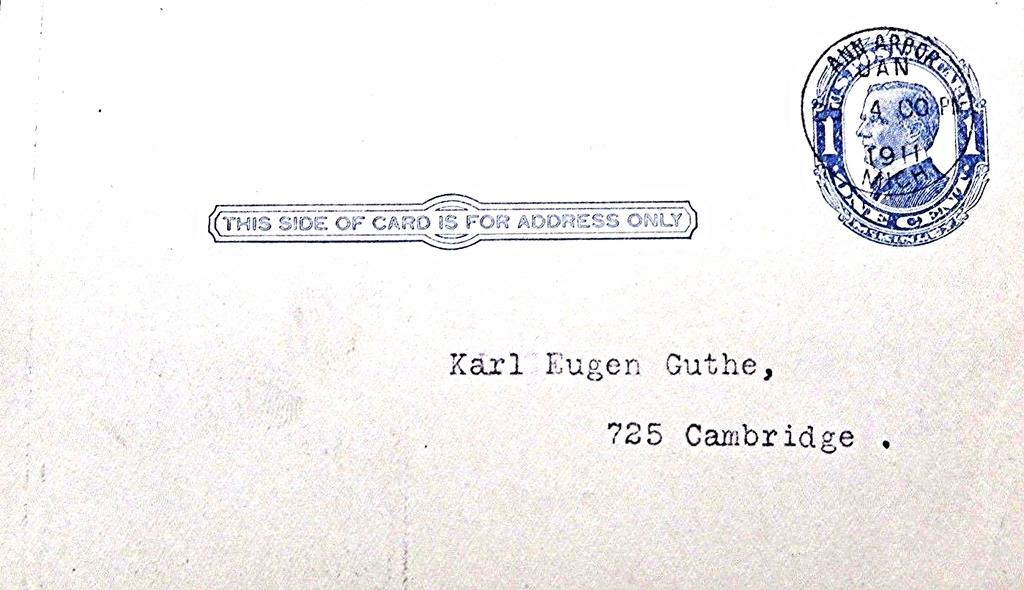Provide a one-sentence caption for the provided image. The old envelope from 1911 is addressed to Karl Eugen Guthe at 725 Cambridge. 